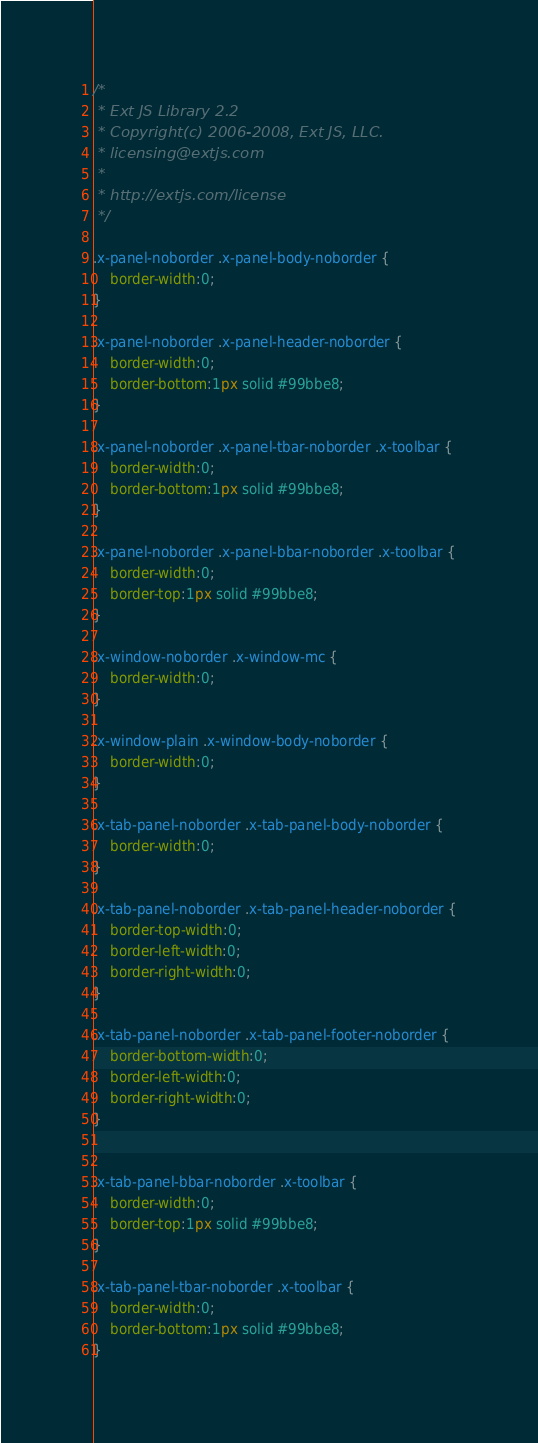<code> <loc_0><loc_0><loc_500><loc_500><_CSS_>/*
 * Ext JS Library 2.2
 * Copyright(c) 2006-2008, Ext JS, LLC.
 * licensing@extjs.com
 * 
 * http://extjs.com/license
 */

.x-panel-noborder .x-panel-body-noborder {
    border-width:0;
}

.x-panel-noborder .x-panel-header-noborder {
    border-width:0;
    border-bottom:1px solid #99bbe8;
}

.x-panel-noborder .x-panel-tbar-noborder .x-toolbar {
    border-width:0;
    border-bottom:1px solid #99bbe8;
}

.x-panel-noborder .x-panel-bbar-noborder .x-toolbar {
    border-width:0;
    border-top:1px solid #99bbe8;
}

.x-window-noborder .x-window-mc {
    border-width:0;
}

.x-window-plain .x-window-body-noborder {
    border-width:0;
}

.x-tab-panel-noborder .x-tab-panel-body-noborder {
	border-width:0;
}

.x-tab-panel-noborder .x-tab-panel-header-noborder {
	border-top-width:0;
	border-left-width:0;
	border-right-width:0;
}

.x-tab-panel-noborder .x-tab-panel-footer-noborder {
	border-bottom-width:0;
	border-left-width:0;
	border-right-width:0;
}


.x-tab-panel-bbar-noborder .x-toolbar {
    border-width:0;
    border-top:1px solid #99bbe8;
}

.x-tab-panel-tbar-noborder .x-toolbar {
    border-width:0;
    border-bottom:1px solid #99bbe8;
}</code> 